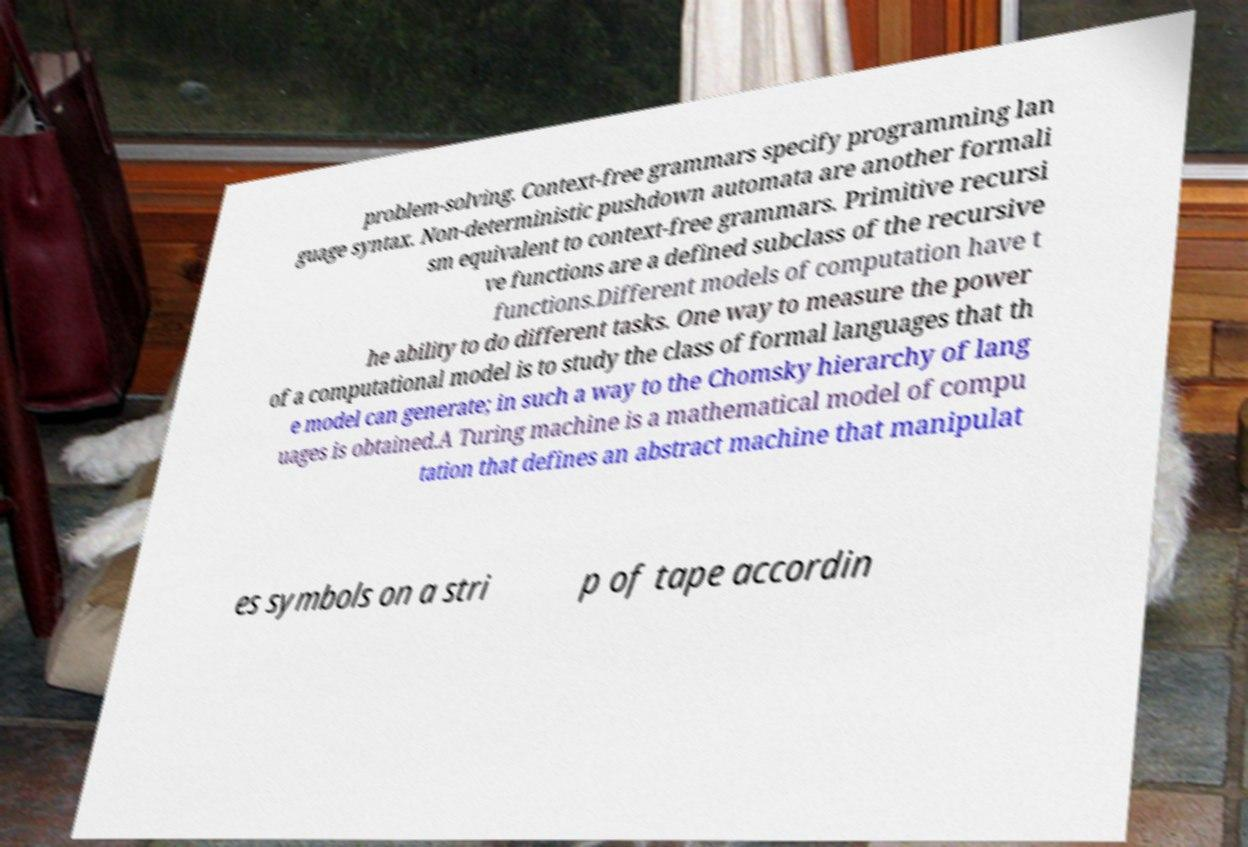I need the written content from this picture converted into text. Can you do that? problem-solving. Context-free grammars specify programming lan guage syntax. Non-deterministic pushdown automata are another formali sm equivalent to context-free grammars. Primitive recursi ve functions are a defined subclass of the recursive functions.Different models of computation have t he ability to do different tasks. One way to measure the power of a computational model is to study the class of formal languages that th e model can generate; in such a way to the Chomsky hierarchy of lang uages is obtained.A Turing machine is a mathematical model of compu tation that defines an abstract machine that manipulat es symbols on a stri p of tape accordin 